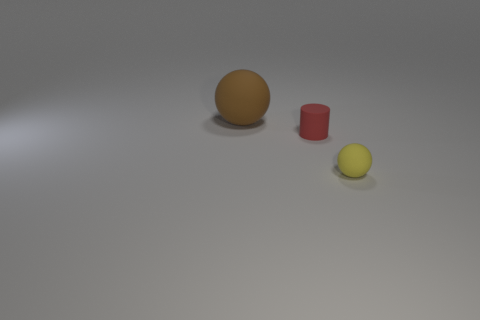What is the ball on the right side of the big thing made of?
Give a very brief answer. Rubber. How big is the rubber ball in front of the matte sphere left of the rubber sphere right of the brown sphere?
Offer a terse response. Small. Is the size of the yellow ball the same as the sphere on the left side of the small rubber sphere?
Provide a succinct answer. No. What color is the rubber sphere to the right of the large rubber thing?
Keep it short and to the point. Yellow. What shape is the rubber object in front of the tiny matte cylinder?
Provide a short and direct response. Sphere. What number of gray objects are either big matte things or small rubber balls?
Offer a very short reply. 0. Are the brown sphere and the small yellow sphere made of the same material?
Your response must be concise. Yes. There is a big brown ball; how many big things are on the left side of it?
Your answer should be very brief. 0. The thing that is in front of the brown matte ball and to the left of the tiny yellow thing is made of what material?
Your answer should be compact. Rubber. What number of cubes are either red objects or small matte things?
Ensure brevity in your answer.  0. 